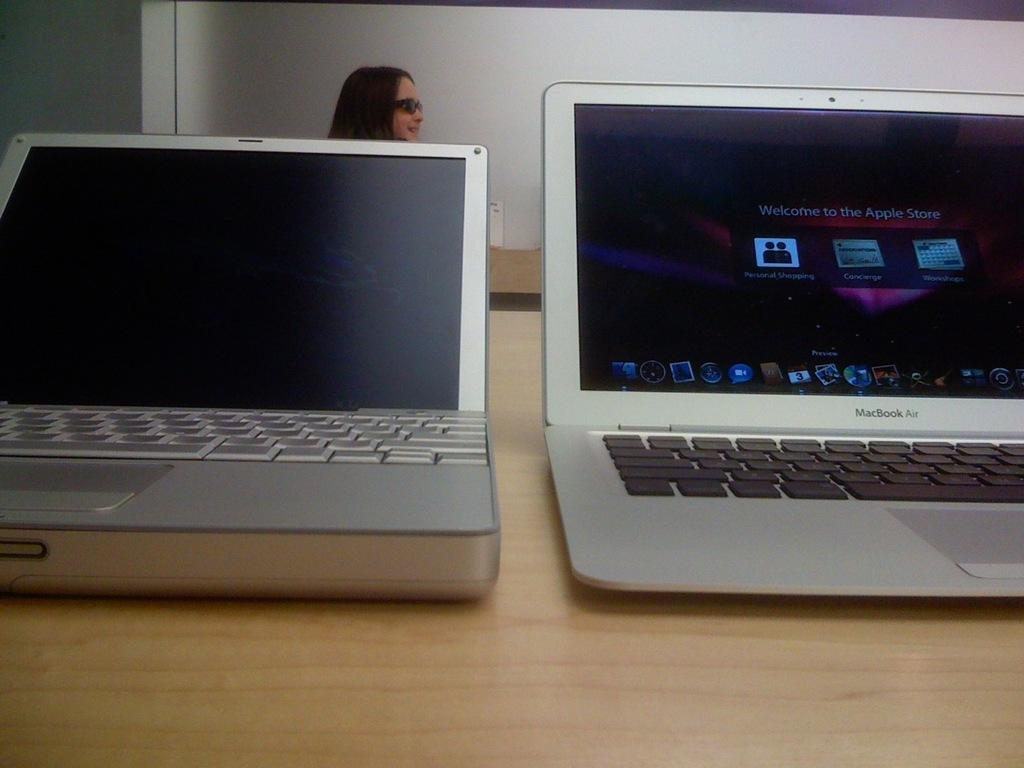<image>
Present a compact description of the photo's key features. Two laptops on display, one is a MacBook Air. 